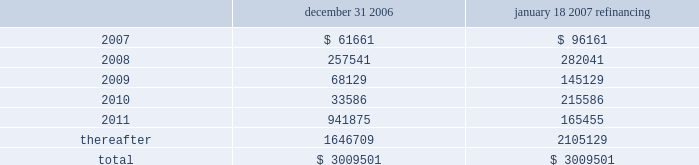Through the certegy merger , the company has an obligation to service $ 200 million ( aggregate principal amount ) of unsecured 4.75% ( 4.75 % ) fixed-rate notes due in 2008 .
The notes were recorded in purchase accounting at a discount of $ 5.7 million , which is being amortized over the term of the notes .
The notes accrue interest at a rate of 4.75% ( 4.75 % ) per year , payable semi-annually in arrears on each march 15 and september 15 .
On april 11 , 2005 , fis entered into interest rate swap agreements which have effectively fixed the interest rate at approximately 5.4% ( 5.4 % ) through april 2008 on $ 350 million of the term loan facilities ( or its replacement debt ) and at approximately 5.2% ( 5.2 % ) through april 2007 on an additional $ 350 million of the term loan .
The company has designated these interest rate swaps as cash flow hedges in accordance with sfas no .
133 .
The estimated fair value of the cash flow hedges results in an asset to the company of $ 4.9 million and $ 5.2 million , as of december 31 , 2006 and december 31 , 2005 , respectively , which is included in the accompanying consolidated balance sheets in other noncurrent assets and as a component of accumulated other comprehensive earnings , net of deferred taxes .
A portion of the amount included in accumulated other comprehensive earnings is reclassified into interest expense as a yield adjustment as interest payments are made on the term loan facilities .
The company 2019s existing cash flow hedges are highly effective and there is no current impact on earnings due to hedge ineffectiveness .
It is the policy of the company to execute such instruments with credit-worthy banks and not to enter into derivative financial instruments for speculative purposes .
Principal maturities at december 31 , 2006 ( and at december 31 , 2006 after giving effect to the debt refinancing completed on january 18 , 2007 ) for the next five years and thereafter are as follows ( in thousands ) : december 31 , january 18 , 2007 refinancing .
Fidelity national information services , inc .
And subsidiaries and affiliates consolidated and combined financial statements notes to consolidated and combined financial statements 2014 ( continued ) .
What was the change , in thousands , of principal maturities due in 2007 after the the debt refinancing completed on january 18 , 2007? 
Computations: (61661 - 96161)
Answer: -34500.0. 